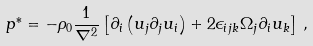<formula> <loc_0><loc_0><loc_500><loc_500>p ^ { * } = - \rho _ { 0 } \frac { 1 } { \nabla ^ { 2 } } \left [ \partial _ { i } \left ( u _ { j } \partial _ { j } u _ { i } \right ) + 2 \epsilon _ { i j k } \Omega _ { j } \partial _ { i } u _ { k } \right ] \, ,</formula> 